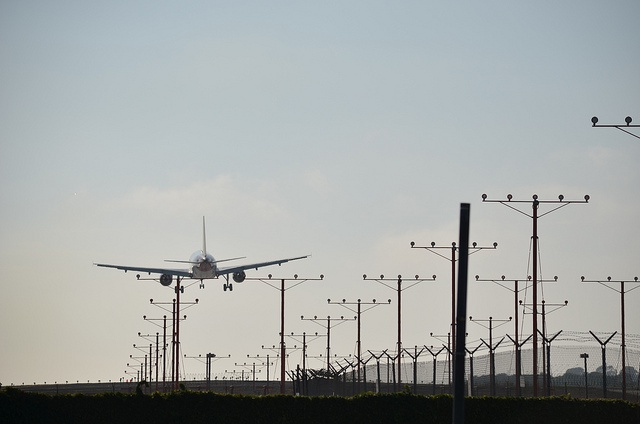Describe the objects in this image and their specific colors. I can see a airplane in darkgray, lightgray, gray, and black tones in this image. 